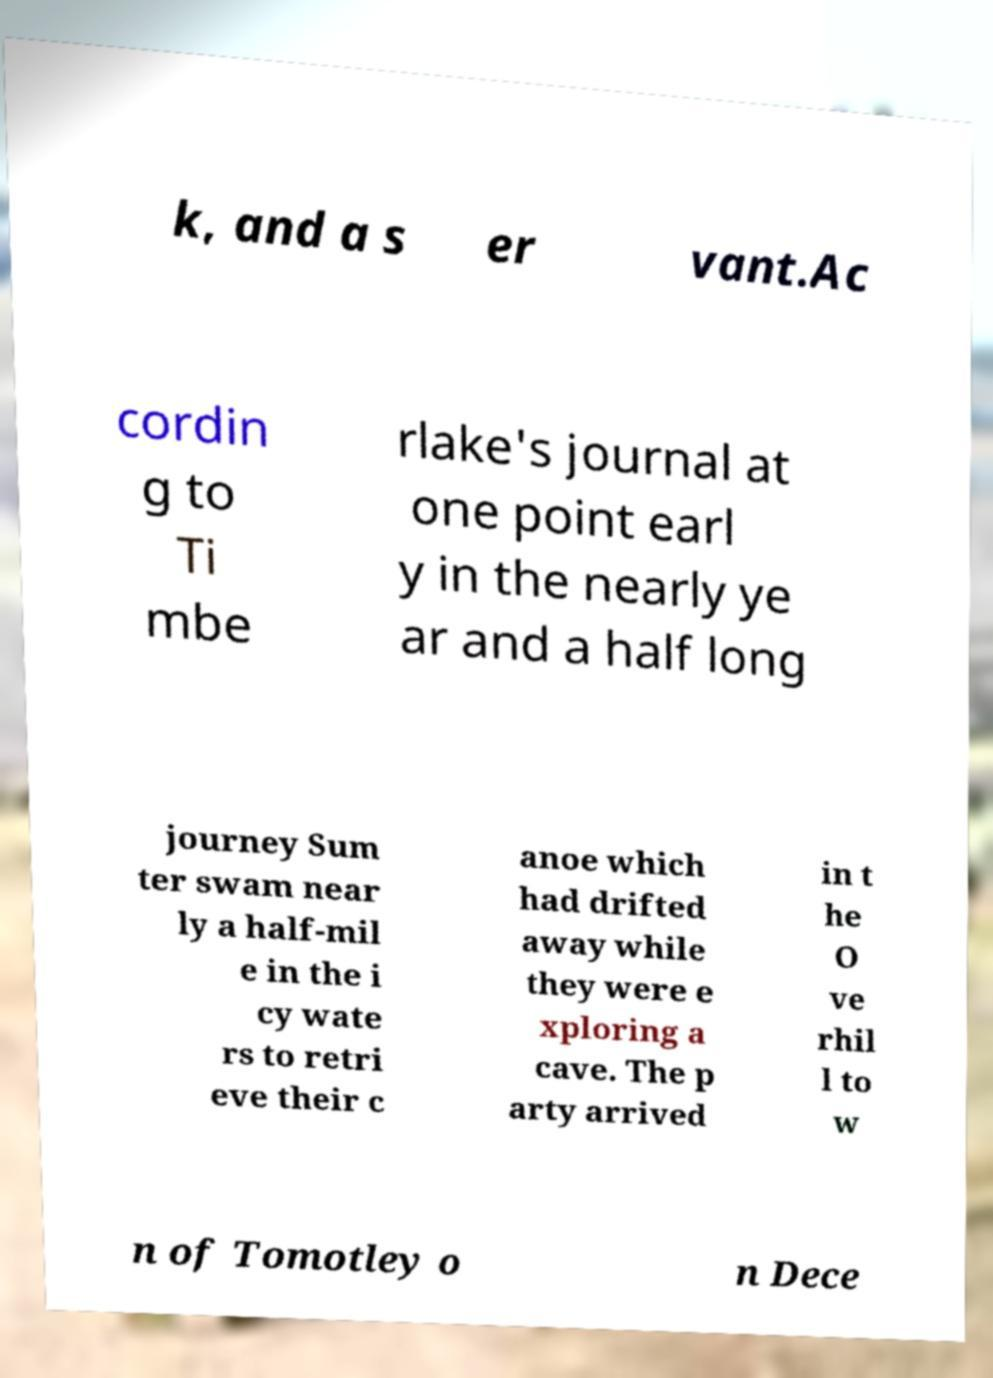I need the written content from this picture converted into text. Can you do that? k, and a s er vant.Ac cordin g to Ti mbe rlake's journal at one point earl y in the nearly ye ar and a half long journey Sum ter swam near ly a half-mil e in the i cy wate rs to retri eve their c anoe which had drifted away while they were e xploring a cave. The p arty arrived in t he O ve rhil l to w n of Tomotley o n Dece 